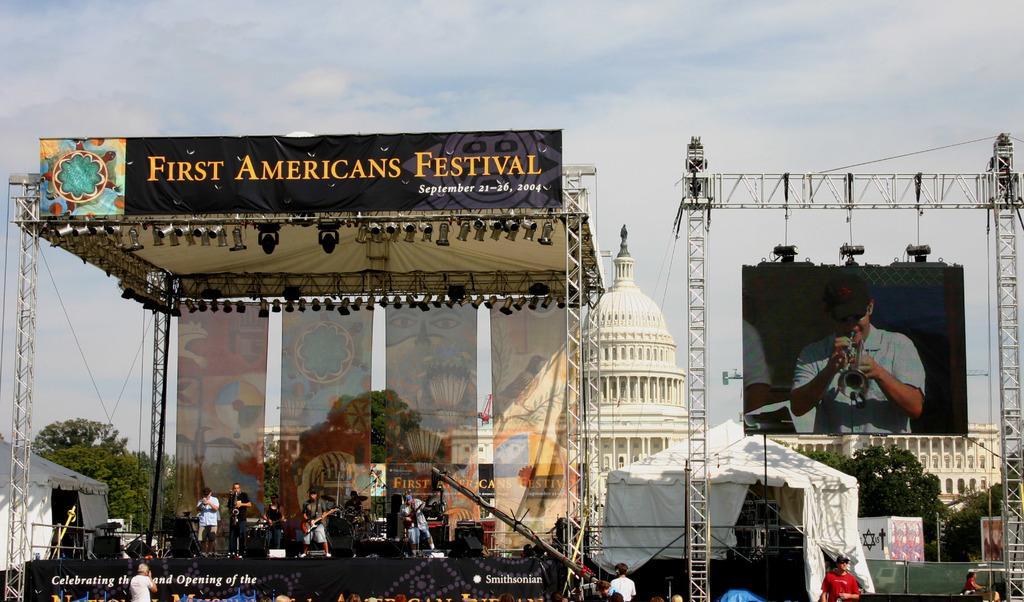In one or two sentences, can you explain what this image depicts? There are some persons performing on a stage as we can see on the left side of this image. There is a screen hanging to a metal object on the right side of this image. There is a building in the background. There are some trees on the left side of this image and right side of this image as well. There is a sky at the top of this image. 